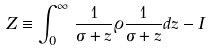<formula> <loc_0><loc_0><loc_500><loc_500>Z \equiv \int _ { 0 } ^ { \infty } \, \frac { 1 } { \sigma + z } \varrho \frac { 1 } { \sigma + z } d z - I</formula> 